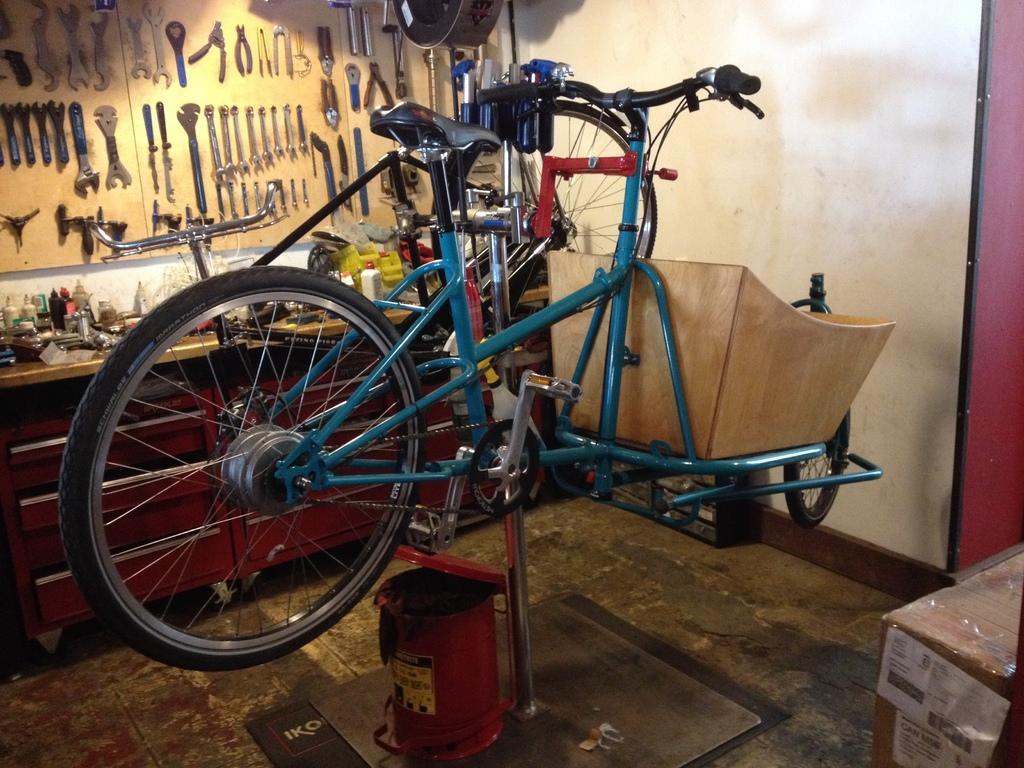How would you summarize this image in a sentence or two? In this picture I can see bicycles to a iron rod, there is a cardboard box, there are wrenches and some other tools on the board ,which is attached to the wall , these look like bottles and there are some other items on the cabinet. 